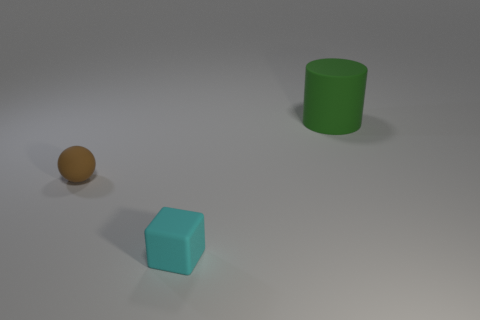Add 1 tiny purple blocks. How many objects exist? 4 Subtract all cubes. How many objects are left? 2 Add 3 green matte objects. How many green matte objects are left? 4 Add 3 large green metallic balls. How many large green metallic balls exist? 3 Subtract 0 cyan cylinders. How many objects are left? 3 Subtract all balls. Subtract all large rubber cylinders. How many objects are left? 1 